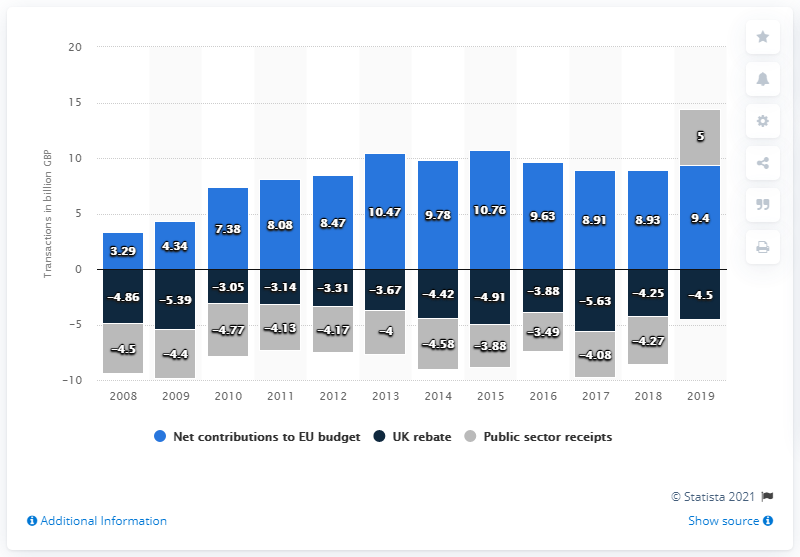List a handful of essential elements in this visual. The UK's net contribution to the European Union in 2019 was 9.4 billion euros. 